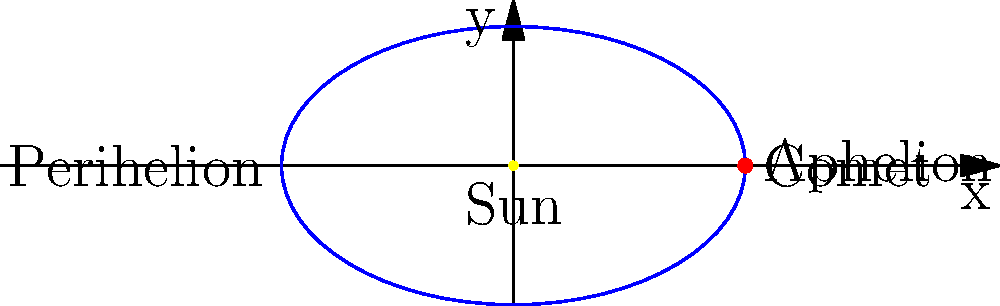In the context of alternative dispute resolution for trust disputes, consider a comet's elliptical orbit around the Sun as an analogy for negotiation dynamics. If the comet's orbit has an eccentricity of 0.8, what is the ratio of its closest approach (perihelion) to its farthest distance (aphelion) from the Sun? To solve this problem, we'll use the properties of elliptical orbits and the definition of eccentricity:

1. The eccentricity (e) of an ellipse is given by: $e = \frac{c}{a}$, where c is the distance from the center to a focus, and a is the semi-major axis.

2. For a comet's orbit, the Sun is at one focus of the ellipse. The perihelion (r_p) and aphelion (r_a) distances are related to the semi-major axis (a) and eccentricity (e) as follows:
   $r_p = a(1-e)$
   $r_a = a(1+e)$

3. We're given that e = 0.8. We need to find the ratio $\frac{r_p}{r_a}$.

4. Dividing the perihelion equation by the aphelion equation:
   $\frac{r_p}{r_a} = \frac{a(1-e)}{a(1+e)}$

5. The 'a' cancels out, leaving us with:
   $\frac{r_p}{r_a} = \frac{1-e}{1+e}$

6. Substituting e = 0.8:
   $\frac{r_p}{r_a} = \frac{1-0.8}{1+0.8} = \frac{0.2}{1.8} = \frac{1}{9}$

This ratio can be interpreted in negotiation contexts as the balance between closest points of agreement and furthest points of disagreement in trust dispute resolutions.
Answer: $\frac{1}{9}$ 